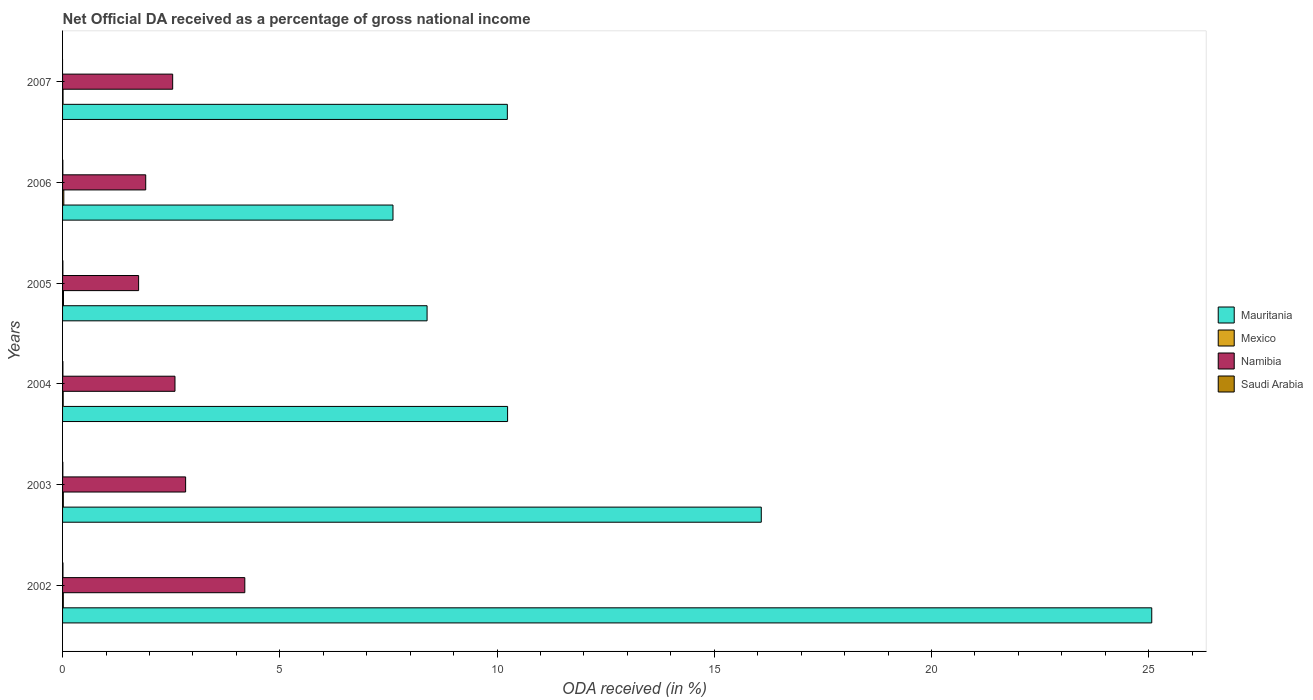How many groups of bars are there?
Offer a very short reply. 6. Are the number of bars per tick equal to the number of legend labels?
Provide a succinct answer. No. Are the number of bars on each tick of the Y-axis equal?
Your answer should be very brief. No. What is the label of the 3rd group of bars from the top?
Provide a succinct answer. 2005. What is the net official DA received in Saudi Arabia in 2004?
Your answer should be very brief. 0.01. Across all years, what is the maximum net official DA received in Namibia?
Offer a very short reply. 4.19. Across all years, what is the minimum net official DA received in Mauritania?
Your answer should be compact. 7.61. What is the total net official DA received in Namibia in the graph?
Your response must be concise. 15.81. What is the difference between the net official DA received in Mexico in 2004 and that in 2007?
Provide a short and direct response. 0. What is the difference between the net official DA received in Mexico in 2005 and the net official DA received in Namibia in 2003?
Keep it short and to the point. -2.81. What is the average net official DA received in Saudi Arabia per year?
Provide a succinct answer. 0.01. In the year 2003, what is the difference between the net official DA received in Mauritania and net official DA received in Mexico?
Provide a short and direct response. 16.06. In how many years, is the net official DA received in Mauritania greater than 11 %?
Provide a short and direct response. 2. What is the ratio of the net official DA received in Saudi Arabia in 2003 to that in 2004?
Provide a succinct answer. 0.83. Is the net official DA received in Mauritania in 2003 less than that in 2007?
Your answer should be very brief. No. Is the difference between the net official DA received in Mauritania in 2002 and 2003 greater than the difference between the net official DA received in Mexico in 2002 and 2003?
Offer a very short reply. Yes. What is the difference between the highest and the second highest net official DA received in Saudi Arabia?
Your answer should be very brief. 0. What is the difference between the highest and the lowest net official DA received in Mexico?
Provide a short and direct response. 0.02. Is the sum of the net official DA received in Mauritania in 2002 and 2005 greater than the maximum net official DA received in Mexico across all years?
Your response must be concise. Yes. Is it the case that in every year, the sum of the net official DA received in Saudi Arabia and net official DA received in Namibia is greater than the sum of net official DA received in Mauritania and net official DA received in Mexico?
Your response must be concise. Yes. Is it the case that in every year, the sum of the net official DA received in Saudi Arabia and net official DA received in Namibia is greater than the net official DA received in Mexico?
Offer a very short reply. Yes. Are all the bars in the graph horizontal?
Your answer should be compact. Yes. What is the difference between two consecutive major ticks on the X-axis?
Your answer should be very brief. 5. Does the graph contain any zero values?
Give a very brief answer. Yes. Does the graph contain grids?
Give a very brief answer. No. What is the title of the graph?
Provide a short and direct response. Net Official DA received as a percentage of gross national income. Does "Least developed countries" appear as one of the legend labels in the graph?
Offer a very short reply. No. What is the label or title of the X-axis?
Offer a very short reply. ODA received (in %). What is the label or title of the Y-axis?
Provide a short and direct response. Years. What is the ODA received (in %) in Mauritania in 2002?
Offer a terse response. 25.07. What is the ODA received (in %) of Mexico in 2002?
Provide a succinct answer. 0.02. What is the ODA received (in %) in Namibia in 2002?
Ensure brevity in your answer.  4.19. What is the ODA received (in %) in Saudi Arabia in 2002?
Offer a terse response. 0.01. What is the ODA received (in %) in Mauritania in 2003?
Your response must be concise. 16.08. What is the ODA received (in %) of Mexico in 2003?
Your response must be concise. 0.02. What is the ODA received (in %) in Namibia in 2003?
Ensure brevity in your answer.  2.83. What is the ODA received (in %) of Saudi Arabia in 2003?
Ensure brevity in your answer.  0.01. What is the ODA received (in %) in Mauritania in 2004?
Your answer should be very brief. 10.24. What is the ODA received (in %) in Mexico in 2004?
Offer a terse response. 0.01. What is the ODA received (in %) of Namibia in 2004?
Your response must be concise. 2.59. What is the ODA received (in %) in Saudi Arabia in 2004?
Provide a succinct answer. 0.01. What is the ODA received (in %) in Mauritania in 2005?
Give a very brief answer. 8.39. What is the ODA received (in %) of Mexico in 2005?
Your response must be concise. 0.02. What is the ODA received (in %) of Namibia in 2005?
Your answer should be very brief. 1.75. What is the ODA received (in %) in Saudi Arabia in 2005?
Your answer should be very brief. 0.01. What is the ODA received (in %) in Mauritania in 2006?
Provide a succinct answer. 7.61. What is the ODA received (in %) of Mexico in 2006?
Provide a short and direct response. 0.03. What is the ODA received (in %) in Namibia in 2006?
Provide a short and direct response. 1.91. What is the ODA received (in %) in Saudi Arabia in 2006?
Give a very brief answer. 0.01. What is the ODA received (in %) in Mauritania in 2007?
Your answer should be very brief. 10.24. What is the ODA received (in %) of Mexico in 2007?
Give a very brief answer. 0.01. What is the ODA received (in %) in Namibia in 2007?
Provide a succinct answer. 2.53. What is the ODA received (in %) of Saudi Arabia in 2007?
Keep it short and to the point. 0. Across all years, what is the maximum ODA received (in %) of Mauritania?
Your response must be concise. 25.07. Across all years, what is the maximum ODA received (in %) in Mexico?
Your answer should be compact. 0.03. Across all years, what is the maximum ODA received (in %) of Namibia?
Offer a very short reply. 4.19. Across all years, what is the maximum ODA received (in %) of Saudi Arabia?
Give a very brief answer. 0.01. Across all years, what is the minimum ODA received (in %) in Mauritania?
Provide a short and direct response. 7.61. Across all years, what is the minimum ODA received (in %) of Mexico?
Make the answer very short. 0.01. Across all years, what is the minimum ODA received (in %) of Namibia?
Provide a short and direct response. 1.75. What is the total ODA received (in %) in Mauritania in the graph?
Give a very brief answer. 77.63. What is the total ODA received (in %) of Mexico in the graph?
Offer a very short reply. 0.11. What is the total ODA received (in %) of Namibia in the graph?
Provide a short and direct response. 15.81. What is the total ODA received (in %) of Saudi Arabia in the graph?
Your answer should be compact. 0.04. What is the difference between the ODA received (in %) of Mauritania in 2002 and that in 2003?
Your answer should be very brief. 8.99. What is the difference between the ODA received (in %) of Mexico in 2002 and that in 2003?
Give a very brief answer. -0. What is the difference between the ODA received (in %) in Namibia in 2002 and that in 2003?
Provide a succinct answer. 1.36. What is the difference between the ODA received (in %) in Saudi Arabia in 2002 and that in 2003?
Give a very brief answer. 0. What is the difference between the ODA received (in %) of Mauritania in 2002 and that in 2004?
Offer a very short reply. 14.83. What is the difference between the ODA received (in %) in Mexico in 2002 and that in 2004?
Offer a terse response. 0. What is the difference between the ODA received (in %) in Namibia in 2002 and that in 2004?
Keep it short and to the point. 1.61. What is the difference between the ODA received (in %) of Saudi Arabia in 2002 and that in 2004?
Offer a very short reply. 0. What is the difference between the ODA received (in %) of Mauritania in 2002 and that in 2005?
Keep it short and to the point. 16.68. What is the difference between the ODA received (in %) of Mexico in 2002 and that in 2005?
Your answer should be compact. -0. What is the difference between the ODA received (in %) in Namibia in 2002 and that in 2005?
Offer a very short reply. 2.44. What is the difference between the ODA received (in %) in Saudi Arabia in 2002 and that in 2005?
Give a very brief answer. 0. What is the difference between the ODA received (in %) in Mauritania in 2002 and that in 2006?
Ensure brevity in your answer.  17.46. What is the difference between the ODA received (in %) in Mexico in 2002 and that in 2006?
Your answer should be very brief. -0.01. What is the difference between the ODA received (in %) of Namibia in 2002 and that in 2006?
Offer a terse response. 2.28. What is the difference between the ODA received (in %) in Saudi Arabia in 2002 and that in 2006?
Offer a terse response. 0. What is the difference between the ODA received (in %) in Mauritania in 2002 and that in 2007?
Make the answer very short. 14.83. What is the difference between the ODA received (in %) of Mexico in 2002 and that in 2007?
Your response must be concise. 0.01. What is the difference between the ODA received (in %) in Namibia in 2002 and that in 2007?
Make the answer very short. 1.66. What is the difference between the ODA received (in %) of Mauritania in 2003 and that in 2004?
Your answer should be compact. 5.84. What is the difference between the ODA received (in %) of Mexico in 2003 and that in 2004?
Make the answer very short. 0. What is the difference between the ODA received (in %) in Namibia in 2003 and that in 2004?
Your response must be concise. 0.25. What is the difference between the ODA received (in %) in Saudi Arabia in 2003 and that in 2004?
Keep it short and to the point. -0. What is the difference between the ODA received (in %) of Mauritania in 2003 and that in 2005?
Give a very brief answer. 7.69. What is the difference between the ODA received (in %) of Mexico in 2003 and that in 2005?
Ensure brevity in your answer.  -0. What is the difference between the ODA received (in %) in Namibia in 2003 and that in 2005?
Offer a very short reply. 1.08. What is the difference between the ODA received (in %) in Saudi Arabia in 2003 and that in 2005?
Give a very brief answer. -0. What is the difference between the ODA received (in %) of Mauritania in 2003 and that in 2006?
Provide a succinct answer. 8.48. What is the difference between the ODA received (in %) of Mexico in 2003 and that in 2006?
Offer a terse response. -0.01. What is the difference between the ODA received (in %) in Namibia in 2003 and that in 2006?
Give a very brief answer. 0.92. What is the difference between the ODA received (in %) in Mauritania in 2003 and that in 2007?
Keep it short and to the point. 5.84. What is the difference between the ODA received (in %) in Mexico in 2003 and that in 2007?
Keep it short and to the point. 0.01. What is the difference between the ODA received (in %) of Namibia in 2003 and that in 2007?
Offer a very short reply. 0.3. What is the difference between the ODA received (in %) of Mauritania in 2004 and that in 2005?
Keep it short and to the point. 1.85. What is the difference between the ODA received (in %) in Mexico in 2004 and that in 2005?
Offer a terse response. -0.01. What is the difference between the ODA received (in %) of Namibia in 2004 and that in 2005?
Your answer should be compact. 0.84. What is the difference between the ODA received (in %) of Mauritania in 2004 and that in 2006?
Make the answer very short. 2.64. What is the difference between the ODA received (in %) in Mexico in 2004 and that in 2006?
Your response must be concise. -0.01. What is the difference between the ODA received (in %) in Namibia in 2004 and that in 2006?
Give a very brief answer. 0.67. What is the difference between the ODA received (in %) in Saudi Arabia in 2004 and that in 2006?
Ensure brevity in your answer.  0. What is the difference between the ODA received (in %) in Mauritania in 2004 and that in 2007?
Offer a very short reply. 0.01. What is the difference between the ODA received (in %) in Mexico in 2004 and that in 2007?
Offer a terse response. 0. What is the difference between the ODA received (in %) of Namibia in 2004 and that in 2007?
Keep it short and to the point. 0.05. What is the difference between the ODA received (in %) of Mauritania in 2005 and that in 2006?
Offer a terse response. 0.78. What is the difference between the ODA received (in %) of Mexico in 2005 and that in 2006?
Your answer should be compact. -0.01. What is the difference between the ODA received (in %) in Namibia in 2005 and that in 2006?
Your answer should be compact. -0.16. What is the difference between the ODA received (in %) in Saudi Arabia in 2005 and that in 2006?
Ensure brevity in your answer.  0. What is the difference between the ODA received (in %) in Mauritania in 2005 and that in 2007?
Ensure brevity in your answer.  -1.85. What is the difference between the ODA received (in %) of Mexico in 2005 and that in 2007?
Your response must be concise. 0.01. What is the difference between the ODA received (in %) of Namibia in 2005 and that in 2007?
Your response must be concise. -0.78. What is the difference between the ODA received (in %) of Mauritania in 2006 and that in 2007?
Give a very brief answer. -2.63. What is the difference between the ODA received (in %) of Mexico in 2006 and that in 2007?
Provide a succinct answer. 0.02. What is the difference between the ODA received (in %) of Namibia in 2006 and that in 2007?
Your answer should be compact. -0.62. What is the difference between the ODA received (in %) in Mauritania in 2002 and the ODA received (in %) in Mexico in 2003?
Make the answer very short. 25.05. What is the difference between the ODA received (in %) in Mauritania in 2002 and the ODA received (in %) in Namibia in 2003?
Make the answer very short. 22.24. What is the difference between the ODA received (in %) of Mauritania in 2002 and the ODA received (in %) of Saudi Arabia in 2003?
Provide a short and direct response. 25.06. What is the difference between the ODA received (in %) in Mexico in 2002 and the ODA received (in %) in Namibia in 2003?
Offer a very short reply. -2.82. What is the difference between the ODA received (in %) of Mexico in 2002 and the ODA received (in %) of Saudi Arabia in 2003?
Provide a short and direct response. 0.01. What is the difference between the ODA received (in %) of Namibia in 2002 and the ODA received (in %) of Saudi Arabia in 2003?
Make the answer very short. 4.19. What is the difference between the ODA received (in %) in Mauritania in 2002 and the ODA received (in %) in Mexico in 2004?
Your answer should be very brief. 25.06. What is the difference between the ODA received (in %) in Mauritania in 2002 and the ODA received (in %) in Namibia in 2004?
Your response must be concise. 22.48. What is the difference between the ODA received (in %) in Mauritania in 2002 and the ODA received (in %) in Saudi Arabia in 2004?
Make the answer very short. 25.06. What is the difference between the ODA received (in %) of Mexico in 2002 and the ODA received (in %) of Namibia in 2004?
Your answer should be very brief. -2.57. What is the difference between the ODA received (in %) in Mexico in 2002 and the ODA received (in %) in Saudi Arabia in 2004?
Make the answer very short. 0.01. What is the difference between the ODA received (in %) in Namibia in 2002 and the ODA received (in %) in Saudi Arabia in 2004?
Your answer should be very brief. 4.19. What is the difference between the ODA received (in %) of Mauritania in 2002 and the ODA received (in %) of Mexico in 2005?
Give a very brief answer. 25.05. What is the difference between the ODA received (in %) in Mauritania in 2002 and the ODA received (in %) in Namibia in 2005?
Offer a very short reply. 23.32. What is the difference between the ODA received (in %) in Mauritania in 2002 and the ODA received (in %) in Saudi Arabia in 2005?
Keep it short and to the point. 25.06. What is the difference between the ODA received (in %) of Mexico in 2002 and the ODA received (in %) of Namibia in 2005?
Give a very brief answer. -1.73. What is the difference between the ODA received (in %) of Mexico in 2002 and the ODA received (in %) of Saudi Arabia in 2005?
Ensure brevity in your answer.  0.01. What is the difference between the ODA received (in %) of Namibia in 2002 and the ODA received (in %) of Saudi Arabia in 2005?
Your response must be concise. 4.19. What is the difference between the ODA received (in %) in Mauritania in 2002 and the ODA received (in %) in Mexico in 2006?
Ensure brevity in your answer.  25.04. What is the difference between the ODA received (in %) in Mauritania in 2002 and the ODA received (in %) in Namibia in 2006?
Keep it short and to the point. 23.16. What is the difference between the ODA received (in %) of Mauritania in 2002 and the ODA received (in %) of Saudi Arabia in 2006?
Make the answer very short. 25.06. What is the difference between the ODA received (in %) of Mexico in 2002 and the ODA received (in %) of Namibia in 2006?
Ensure brevity in your answer.  -1.9. What is the difference between the ODA received (in %) in Mexico in 2002 and the ODA received (in %) in Saudi Arabia in 2006?
Offer a very short reply. 0.01. What is the difference between the ODA received (in %) of Namibia in 2002 and the ODA received (in %) of Saudi Arabia in 2006?
Your response must be concise. 4.19. What is the difference between the ODA received (in %) in Mauritania in 2002 and the ODA received (in %) in Mexico in 2007?
Offer a very short reply. 25.06. What is the difference between the ODA received (in %) of Mauritania in 2002 and the ODA received (in %) of Namibia in 2007?
Give a very brief answer. 22.54. What is the difference between the ODA received (in %) of Mexico in 2002 and the ODA received (in %) of Namibia in 2007?
Give a very brief answer. -2.52. What is the difference between the ODA received (in %) of Mauritania in 2003 and the ODA received (in %) of Mexico in 2004?
Provide a succinct answer. 16.07. What is the difference between the ODA received (in %) of Mauritania in 2003 and the ODA received (in %) of Namibia in 2004?
Offer a very short reply. 13.49. What is the difference between the ODA received (in %) in Mauritania in 2003 and the ODA received (in %) in Saudi Arabia in 2004?
Make the answer very short. 16.07. What is the difference between the ODA received (in %) in Mexico in 2003 and the ODA received (in %) in Namibia in 2004?
Your answer should be very brief. -2.57. What is the difference between the ODA received (in %) of Mexico in 2003 and the ODA received (in %) of Saudi Arabia in 2004?
Give a very brief answer. 0.01. What is the difference between the ODA received (in %) of Namibia in 2003 and the ODA received (in %) of Saudi Arabia in 2004?
Keep it short and to the point. 2.82. What is the difference between the ODA received (in %) of Mauritania in 2003 and the ODA received (in %) of Mexico in 2005?
Offer a very short reply. 16.06. What is the difference between the ODA received (in %) in Mauritania in 2003 and the ODA received (in %) in Namibia in 2005?
Provide a short and direct response. 14.33. What is the difference between the ODA received (in %) in Mauritania in 2003 and the ODA received (in %) in Saudi Arabia in 2005?
Ensure brevity in your answer.  16.07. What is the difference between the ODA received (in %) of Mexico in 2003 and the ODA received (in %) of Namibia in 2005?
Offer a very short reply. -1.73. What is the difference between the ODA received (in %) in Mexico in 2003 and the ODA received (in %) in Saudi Arabia in 2005?
Your answer should be compact. 0.01. What is the difference between the ODA received (in %) of Namibia in 2003 and the ODA received (in %) of Saudi Arabia in 2005?
Keep it short and to the point. 2.83. What is the difference between the ODA received (in %) of Mauritania in 2003 and the ODA received (in %) of Mexico in 2006?
Offer a terse response. 16.05. What is the difference between the ODA received (in %) of Mauritania in 2003 and the ODA received (in %) of Namibia in 2006?
Your answer should be very brief. 14.17. What is the difference between the ODA received (in %) in Mauritania in 2003 and the ODA received (in %) in Saudi Arabia in 2006?
Your response must be concise. 16.08. What is the difference between the ODA received (in %) in Mexico in 2003 and the ODA received (in %) in Namibia in 2006?
Provide a short and direct response. -1.9. What is the difference between the ODA received (in %) in Mexico in 2003 and the ODA received (in %) in Saudi Arabia in 2006?
Provide a succinct answer. 0.01. What is the difference between the ODA received (in %) in Namibia in 2003 and the ODA received (in %) in Saudi Arabia in 2006?
Make the answer very short. 2.83. What is the difference between the ODA received (in %) of Mauritania in 2003 and the ODA received (in %) of Mexico in 2007?
Your response must be concise. 16.07. What is the difference between the ODA received (in %) in Mauritania in 2003 and the ODA received (in %) in Namibia in 2007?
Your answer should be very brief. 13.55. What is the difference between the ODA received (in %) in Mexico in 2003 and the ODA received (in %) in Namibia in 2007?
Your response must be concise. -2.52. What is the difference between the ODA received (in %) in Mauritania in 2004 and the ODA received (in %) in Mexico in 2005?
Your answer should be very brief. 10.22. What is the difference between the ODA received (in %) in Mauritania in 2004 and the ODA received (in %) in Namibia in 2005?
Provide a succinct answer. 8.49. What is the difference between the ODA received (in %) in Mauritania in 2004 and the ODA received (in %) in Saudi Arabia in 2005?
Provide a succinct answer. 10.24. What is the difference between the ODA received (in %) in Mexico in 2004 and the ODA received (in %) in Namibia in 2005?
Your response must be concise. -1.74. What is the difference between the ODA received (in %) of Mexico in 2004 and the ODA received (in %) of Saudi Arabia in 2005?
Your response must be concise. 0.01. What is the difference between the ODA received (in %) in Namibia in 2004 and the ODA received (in %) in Saudi Arabia in 2005?
Your answer should be compact. 2.58. What is the difference between the ODA received (in %) in Mauritania in 2004 and the ODA received (in %) in Mexico in 2006?
Keep it short and to the point. 10.21. What is the difference between the ODA received (in %) in Mauritania in 2004 and the ODA received (in %) in Namibia in 2006?
Make the answer very short. 8.33. What is the difference between the ODA received (in %) in Mauritania in 2004 and the ODA received (in %) in Saudi Arabia in 2006?
Make the answer very short. 10.24. What is the difference between the ODA received (in %) in Mexico in 2004 and the ODA received (in %) in Namibia in 2006?
Provide a succinct answer. -1.9. What is the difference between the ODA received (in %) of Mexico in 2004 and the ODA received (in %) of Saudi Arabia in 2006?
Offer a very short reply. 0.01. What is the difference between the ODA received (in %) of Namibia in 2004 and the ODA received (in %) of Saudi Arabia in 2006?
Give a very brief answer. 2.58. What is the difference between the ODA received (in %) of Mauritania in 2004 and the ODA received (in %) of Mexico in 2007?
Give a very brief answer. 10.23. What is the difference between the ODA received (in %) in Mauritania in 2004 and the ODA received (in %) in Namibia in 2007?
Keep it short and to the point. 7.71. What is the difference between the ODA received (in %) in Mexico in 2004 and the ODA received (in %) in Namibia in 2007?
Offer a very short reply. -2.52. What is the difference between the ODA received (in %) of Mauritania in 2005 and the ODA received (in %) of Mexico in 2006?
Provide a succinct answer. 8.36. What is the difference between the ODA received (in %) of Mauritania in 2005 and the ODA received (in %) of Namibia in 2006?
Offer a very short reply. 6.48. What is the difference between the ODA received (in %) of Mauritania in 2005 and the ODA received (in %) of Saudi Arabia in 2006?
Keep it short and to the point. 8.38. What is the difference between the ODA received (in %) of Mexico in 2005 and the ODA received (in %) of Namibia in 2006?
Ensure brevity in your answer.  -1.89. What is the difference between the ODA received (in %) in Mexico in 2005 and the ODA received (in %) in Saudi Arabia in 2006?
Ensure brevity in your answer.  0.01. What is the difference between the ODA received (in %) in Namibia in 2005 and the ODA received (in %) in Saudi Arabia in 2006?
Your response must be concise. 1.74. What is the difference between the ODA received (in %) in Mauritania in 2005 and the ODA received (in %) in Mexico in 2007?
Give a very brief answer. 8.38. What is the difference between the ODA received (in %) in Mauritania in 2005 and the ODA received (in %) in Namibia in 2007?
Ensure brevity in your answer.  5.86. What is the difference between the ODA received (in %) in Mexico in 2005 and the ODA received (in %) in Namibia in 2007?
Make the answer very short. -2.51. What is the difference between the ODA received (in %) of Mauritania in 2006 and the ODA received (in %) of Mexico in 2007?
Ensure brevity in your answer.  7.59. What is the difference between the ODA received (in %) in Mauritania in 2006 and the ODA received (in %) in Namibia in 2007?
Your response must be concise. 5.07. What is the difference between the ODA received (in %) of Mexico in 2006 and the ODA received (in %) of Namibia in 2007?
Make the answer very short. -2.51. What is the average ODA received (in %) in Mauritania per year?
Give a very brief answer. 12.94. What is the average ODA received (in %) of Mexico per year?
Your answer should be very brief. 0.02. What is the average ODA received (in %) in Namibia per year?
Give a very brief answer. 2.64. What is the average ODA received (in %) in Saudi Arabia per year?
Your answer should be compact. 0.01. In the year 2002, what is the difference between the ODA received (in %) of Mauritania and ODA received (in %) of Mexico?
Offer a terse response. 25.05. In the year 2002, what is the difference between the ODA received (in %) of Mauritania and ODA received (in %) of Namibia?
Offer a terse response. 20.88. In the year 2002, what is the difference between the ODA received (in %) of Mauritania and ODA received (in %) of Saudi Arabia?
Provide a succinct answer. 25.06. In the year 2002, what is the difference between the ODA received (in %) in Mexico and ODA received (in %) in Namibia?
Provide a succinct answer. -4.18. In the year 2002, what is the difference between the ODA received (in %) of Mexico and ODA received (in %) of Saudi Arabia?
Offer a terse response. 0.01. In the year 2002, what is the difference between the ODA received (in %) of Namibia and ODA received (in %) of Saudi Arabia?
Provide a succinct answer. 4.19. In the year 2003, what is the difference between the ODA received (in %) in Mauritania and ODA received (in %) in Mexico?
Make the answer very short. 16.06. In the year 2003, what is the difference between the ODA received (in %) in Mauritania and ODA received (in %) in Namibia?
Your response must be concise. 13.25. In the year 2003, what is the difference between the ODA received (in %) of Mauritania and ODA received (in %) of Saudi Arabia?
Keep it short and to the point. 16.08. In the year 2003, what is the difference between the ODA received (in %) in Mexico and ODA received (in %) in Namibia?
Your response must be concise. -2.82. In the year 2003, what is the difference between the ODA received (in %) of Mexico and ODA received (in %) of Saudi Arabia?
Make the answer very short. 0.01. In the year 2003, what is the difference between the ODA received (in %) in Namibia and ODA received (in %) in Saudi Arabia?
Ensure brevity in your answer.  2.83. In the year 2004, what is the difference between the ODA received (in %) of Mauritania and ODA received (in %) of Mexico?
Keep it short and to the point. 10.23. In the year 2004, what is the difference between the ODA received (in %) of Mauritania and ODA received (in %) of Namibia?
Give a very brief answer. 7.66. In the year 2004, what is the difference between the ODA received (in %) in Mauritania and ODA received (in %) in Saudi Arabia?
Provide a succinct answer. 10.24. In the year 2004, what is the difference between the ODA received (in %) in Mexico and ODA received (in %) in Namibia?
Keep it short and to the point. -2.57. In the year 2004, what is the difference between the ODA received (in %) of Mexico and ODA received (in %) of Saudi Arabia?
Give a very brief answer. 0.01. In the year 2004, what is the difference between the ODA received (in %) in Namibia and ODA received (in %) in Saudi Arabia?
Offer a very short reply. 2.58. In the year 2005, what is the difference between the ODA received (in %) in Mauritania and ODA received (in %) in Mexico?
Keep it short and to the point. 8.37. In the year 2005, what is the difference between the ODA received (in %) in Mauritania and ODA received (in %) in Namibia?
Offer a very short reply. 6.64. In the year 2005, what is the difference between the ODA received (in %) of Mauritania and ODA received (in %) of Saudi Arabia?
Provide a succinct answer. 8.38. In the year 2005, what is the difference between the ODA received (in %) of Mexico and ODA received (in %) of Namibia?
Make the answer very short. -1.73. In the year 2005, what is the difference between the ODA received (in %) in Mexico and ODA received (in %) in Saudi Arabia?
Offer a very short reply. 0.01. In the year 2005, what is the difference between the ODA received (in %) of Namibia and ODA received (in %) of Saudi Arabia?
Your answer should be compact. 1.74. In the year 2006, what is the difference between the ODA received (in %) of Mauritania and ODA received (in %) of Mexico?
Give a very brief answer. 7.58. In the year 2006, what is the difference between the ODA received (in %) in Mauritania and ODA received (in %) in Namibia?
Provide a succinct answer. 5.69. In the year 2006, what is the difference between the ODA received (in %) in Mauritania and ODA received (in %) in Saudi Arabia?
Offer a terse response. 7.6. In the year 2006, what is the difference between the ODA received (in %) of Mexico and ODA received (in %) of Namibia?
Give a very brief answer. -1.89. In the year 2006, what is the difference between the ODA received (in %) of Mexico and ODA received (in %) of Saudi Arabia?
Offer a very short reply. 0.02. In the year 2006, what is the difference between the ODA received (in %) in Namibia and ODA received (in %) in Saudi Arabia?
Your answer should be very brief. 1.91. In the year 2007, what is the difference between the ODA received (in %) in Mauritania and ODA received (in %) in Mexico?
Your answer should be very brief. 10.23. In the year 2007, what is the difference between the ODA received (in %) in Mauritania and ODA received (in %) in Namibia?
Make the answer very short. 7.7. In the year 2007, what is the difference between the ODA received (in %) in Mexico and ODA received (in %) in Namibia?
Offer a terse response. -2.52. What is the ratio of the ODA received (in %) in Mauritania in 2002 to that in 2003?
Keep it short and to the point. 1.56. What is the ratio of the ODA received (in %) of Mexico in 2002 to that in 2003?
Your answer should be very brief. 0.98. What is the ratio of the ODA received (in %) in Namibia in 2002 to that in 2003?
Keep it short and to the point. 1.48. What is the ratio of the ODA received (in %) in Saudi Arabia in 2002 to that in 2003?
Keep it short and to the point. 1.41. What is the ratio of the ODA received (in %) in Mauritania in 2002 to that in 2004?
Ensure brevity in your answer.  2.45. What is the ratio of the ODA received (in %) in Mexico in 2002 to that in 2004?
Your answer should be compact. 1.21. What is the ratio of the ODA received (in %) in Namibia in 2002 to that in 2004?
Your answer should be compact. 1.62. What is the ratio of the ODA received (in %) of Saudi Arabia in 2002 to that in 2004?
Ensure brevity in your answer.  1.17. What is the ratio of the ODA received (in %) of Mauritania in 2002 to that in 2005?
Your answer should be compact. 2.99. What is the ratio of the ODA received (in %) of Mexico in 2002 to that in 2005?
Keep it short and to the point. 0.81. What is the ratio of the ODA received (in %) of Namibia in 2002 to that in 2005?
Provide a short and direct response. 2.4. What is the ratio of the ODA received (in %) of Saudi Arabia in 2002 to that in 2005?
Provide a short and direct response. 1.21. What is the ratio of the ODA received (in %) of Mauritania in 2002 to that in 2006?
Provide a short and direct response. 3.3. What is the ratio of the ODA received (in %) of Mexico in 2002 to that in 2006?
Your response must be concise. 0.6. What is the ratio of the ODA received (in %) of Namibia in 2002 to that in 2006?
Provide a succinct answer. 2.19. What is the ratio of the ODA received (in %) of Saudi Arabia in 2002 to that in 2006?
Keep it short and to the point. 1.44. What is the ratio of the ODA received (in %) of Mauritania in 2002 to that in 2007?
Offer a very short reply. 2.45. What is the ratio of the ODA received (in %) of Mexico in 2002 to that in 2007?
Offer a terse response. 1.54. What is the ratio of the ODA received (in %) of Namibia in 2002 to that in 2007?
Ensure brevity in your answer.  1.66. What is the ratio of the ODA received (in %) in Mauritania in 2003 to that in 2004?
Make the answer very short. 1.57. What is the ratio of the ODA received (in %) in Mexico in 2003 to that in 2004?
Provide a succinct answer. 1.24. What is the ratio of the ODA received (in %) in Namibia in 2003 to that in 2004?
Your response must be concise. 1.09. What is the ratio of the ODA received (in %) of Saudi Arabia in 2003 to that in 2004?
Offer a very short reply. 0.83. What is the ratio of the ODA received (in %) of Mauritania in 2003 to that in 2005?
Provide a short and direct response. 1.92. What is the ratio of the ODA received (in %) of Mexico in 2003 to that in 2005?
Provide a succinct answer. 0.83. What is the ratio of the ODA received (in %) of Namibia in 2003 to that in 2005?
Make the answer very short. 1.62. What is the ratio of the ODA received (in %) of Saudi Arabia in 2003 to that in 2005?
Provide a short and direct response. 0.86. What is the ratio of the ODA received (in %) in Mauritania in 2003 to that in 2006?
Your response must be concise. 2.11. What is the ratio of the ODA received (in %) of Mexico in 2003 to that in 2006?
Offer a terse response. 0.61. What is the ratio of the ODA received (in %) of Namibia in 2003 to that in 2006?
Make the answer very short. 1.48. What is the ratio of the ODA received (in %) of Saudi Arabia in 2003 to that in 2006?
Your answer should be compact. 1.03. What is the ratio of the ODA received (in %) of Mauritania in 2003 to that in 2007?
Provide a short and direct response. 1.57. What is the ratio of the ODA received (in %) in Mexico in 2003 to that in 2007?
Your answer should be compact. 1.58. What is the ratio of the ODA received (in %) of Namibia in 2003 to that in 2007?
Your answer should be very brief. 1.12. What is the ratio of the ODA received (in %) of Mauritania in 2004 to that in 2005?
Your response must be concise. 1.22. What is the ratio of the ODA received (in %) of Mexico in 2004 to that in 2005?
Provide a succinct answer. 0.67. What is the ratio of the ODA received (in %) of Namibia in 2004 to that in 2005?
Keep it short and to the point. 1.48. What is the ratio of the ODA received (in %) in Saudi Arabia in 2004 to that in 2005?
Give a very brief answer. 1.04. What is the ratio of the ODA received (in %) of Mauritania in 2004 to that in 2006?
Your answer should be very brief. 1.35. What is the ratio of the ODA received (in %) of Mexico in 2004 to that in 2006?
Your answer should be very brief. 0.5. What is the ratio of the ODA received (in %) in Namibia in 2004 to that in 2006?
Provide a succinct answer. 1.35. What is the ratio of the ODA received (in %) in Saudi Arabia in 2004 to that in 2006?
Offer a very short reply. 1.23. What is the ratio of the ODA received (in %) in Mexico in 2004 to that in 2007?
Your response must be concise. 1.28. What is the ratio of the ODA received (in %) in Namibia in 2004 to that in 2007?
Your response must be concise. 1.02. What is the ratio of the ODA received (in %) of Mauritania in 2005 to that in 2006?
Ensure brevity in your answer.  1.1. What is the ratio of the ODA received (in %) of Mexico in 2005 to that in 2006?
Offer a terse response. 0.74. What is the ratio of the ODA received (in %) of Namibia in 2005 to that in 2006?
Your answer should be very brief. 0.91. What is the ratio of the ODA received (in %) in Saudi Arabia in 2005 to that in 2006?
Offer a terse response. 1.19. What is the ratio of the ODA received (in %) of Mauritania in 2005 to that in 2007?
Your response must be concise. 0.82. What is the ratio of the ODA received (in %) of Mexico in 2005 to that in 2007?
Provide a short and direct response. 1.91. What is the ratio of the ODA received (in %) of Namibia in 2005 to that in 2007?
Keep it short and to the point. 0.69. What is the ratio of the ODA received (in %) in Mauritania in 2006 to that in 2007?
Your answer should be very brief. 0.74. What is the ratio of the ODA received (in %) of Mexico in 2006 to that in 2007?
Keep it short and to the point. 2.57. What is the ratio of the ODA received (in %) in Namibia in 2006 to that in 2007?
Provide a short and direct response. 0.76. What is the difference between the highest and the second highest ODA received (in %) of Mauritania?
Your response must be concise. 8.99. What is the difference between the highest and the second highest ODA received (in %) in Mexico?
Your answer should be very brief. 0.01. What is the difference between the highest and the second highest ODA received (in %) in Namibia?
Your response must be concise. 1.36. What is the difference between the highest and the second highest ODA received (in %) of Saudi Arabia?
Give a very brief answer. 0. What is the difference between the highest and the lowest ODA received (in %) in Mauritania?
Offer a very short reply. 17.46. What is the difference between the highest and the lowest ODA received (in %) of Mexico?
Your response must be concise. 0.02. What is the difference between the highest and the lowest ODA received (in %) in Namibia?
Your answer should be compact. 2.44. What is the difference between the highest and the lowest ODA received (in %) of Saudi Arabia?
Offer a very short reply. 0.01. 